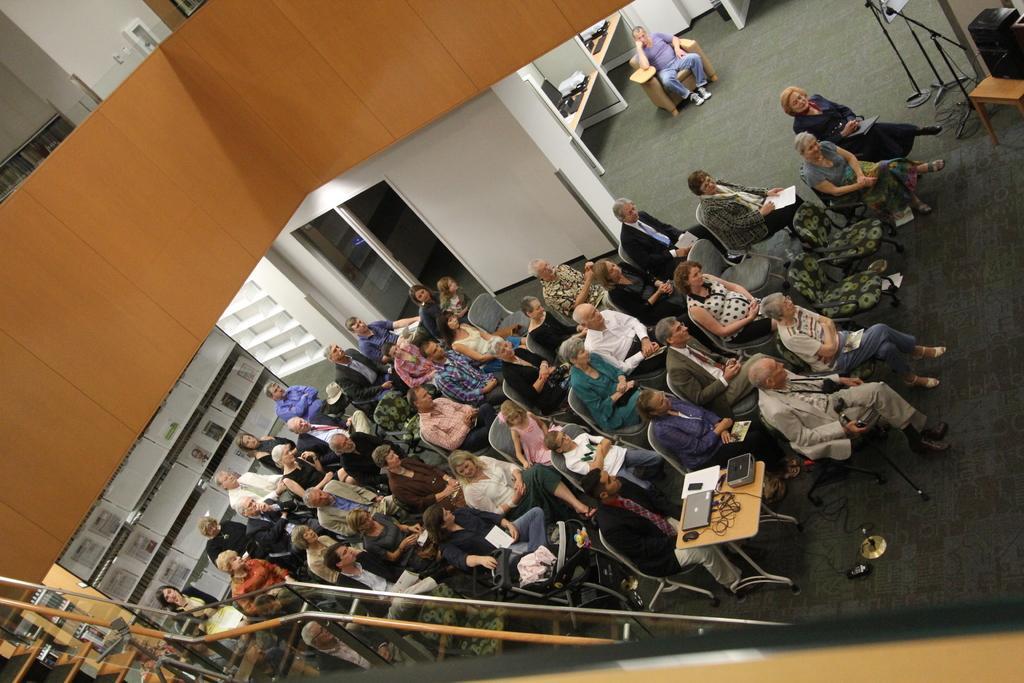In one or two sentences, can you explain what this image depicts? In this image in the center there are persons sitting on the chair there is a table in the center, on the table there are papers, there is a laptop and there are wires and black colour object. In the front there is a staircase. In the background there is a person sitting and there are desks and on the desk there are computers and there is a door. On the right side there is an object which is black in colour on the stool and there is a mic and there are stands which are black in colour. 